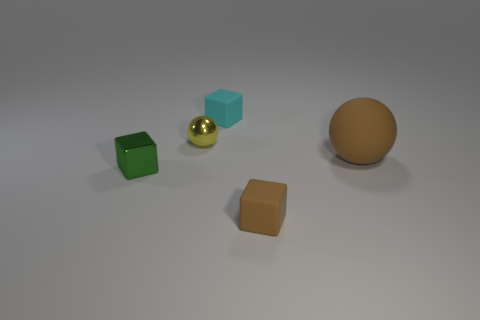Add 3 tiny purple blocks. How many objects exist? 8 Subtract all spheres. How many objects are left? 3 Subtract 0 green cylinders. How many objects are left? 5 Subtract all big yellow metal balls. Subtract all tiny things. How many objects are left? 1 Add 5 shiny blocks. How many shiny blocks are left? 6 Add 3 small red rubber cylinders. How many small red rubber cylinders exist? 3 